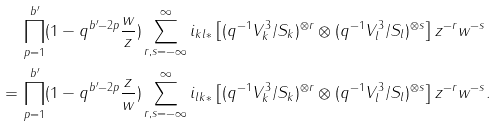<formula> <loc_0><loc_0><loc_500><loc_500>& \prod _ { p = 1 } ^ { b ^ { \prime } } ( 1 - q ^ { b ^ { \prime } - 2 p } \frac { w } { z } ) \sum _ { r , s = - \infty } ^ { \infty } i _ { k l * } \left [ ( q ^ { - 1 } V ^ { 3 } _ { k } / S _ { k } ) ^ { \otimes r } \otimes ( q ^ { - 1 } V ^ { 3 } _ { l } / S _ { l } ) ^ { \otimes s } \right ] z ^ { - r } w ^ { - s } \\ = \, & \prod _ { p = 1 } ^ { b ^ { \prime } } ( 1 - q ^ { b ^ { \prime } - 2 p } \frac { z } { w } ) \sum _ { r , s = - \infty } ^ { \infty } i _ { l k * } \left [ ( q ^ { - 1 } V ^ { 3 } _ { k } / S _ { k } ) ^ { \otimes r } \otimes ( q ^ { - 1 } V ^ { 3 } _ { l } / S _ { l } ) ^ { \otimes s } \right ] z ^ { - r } w ^ { - s } .</formula> 